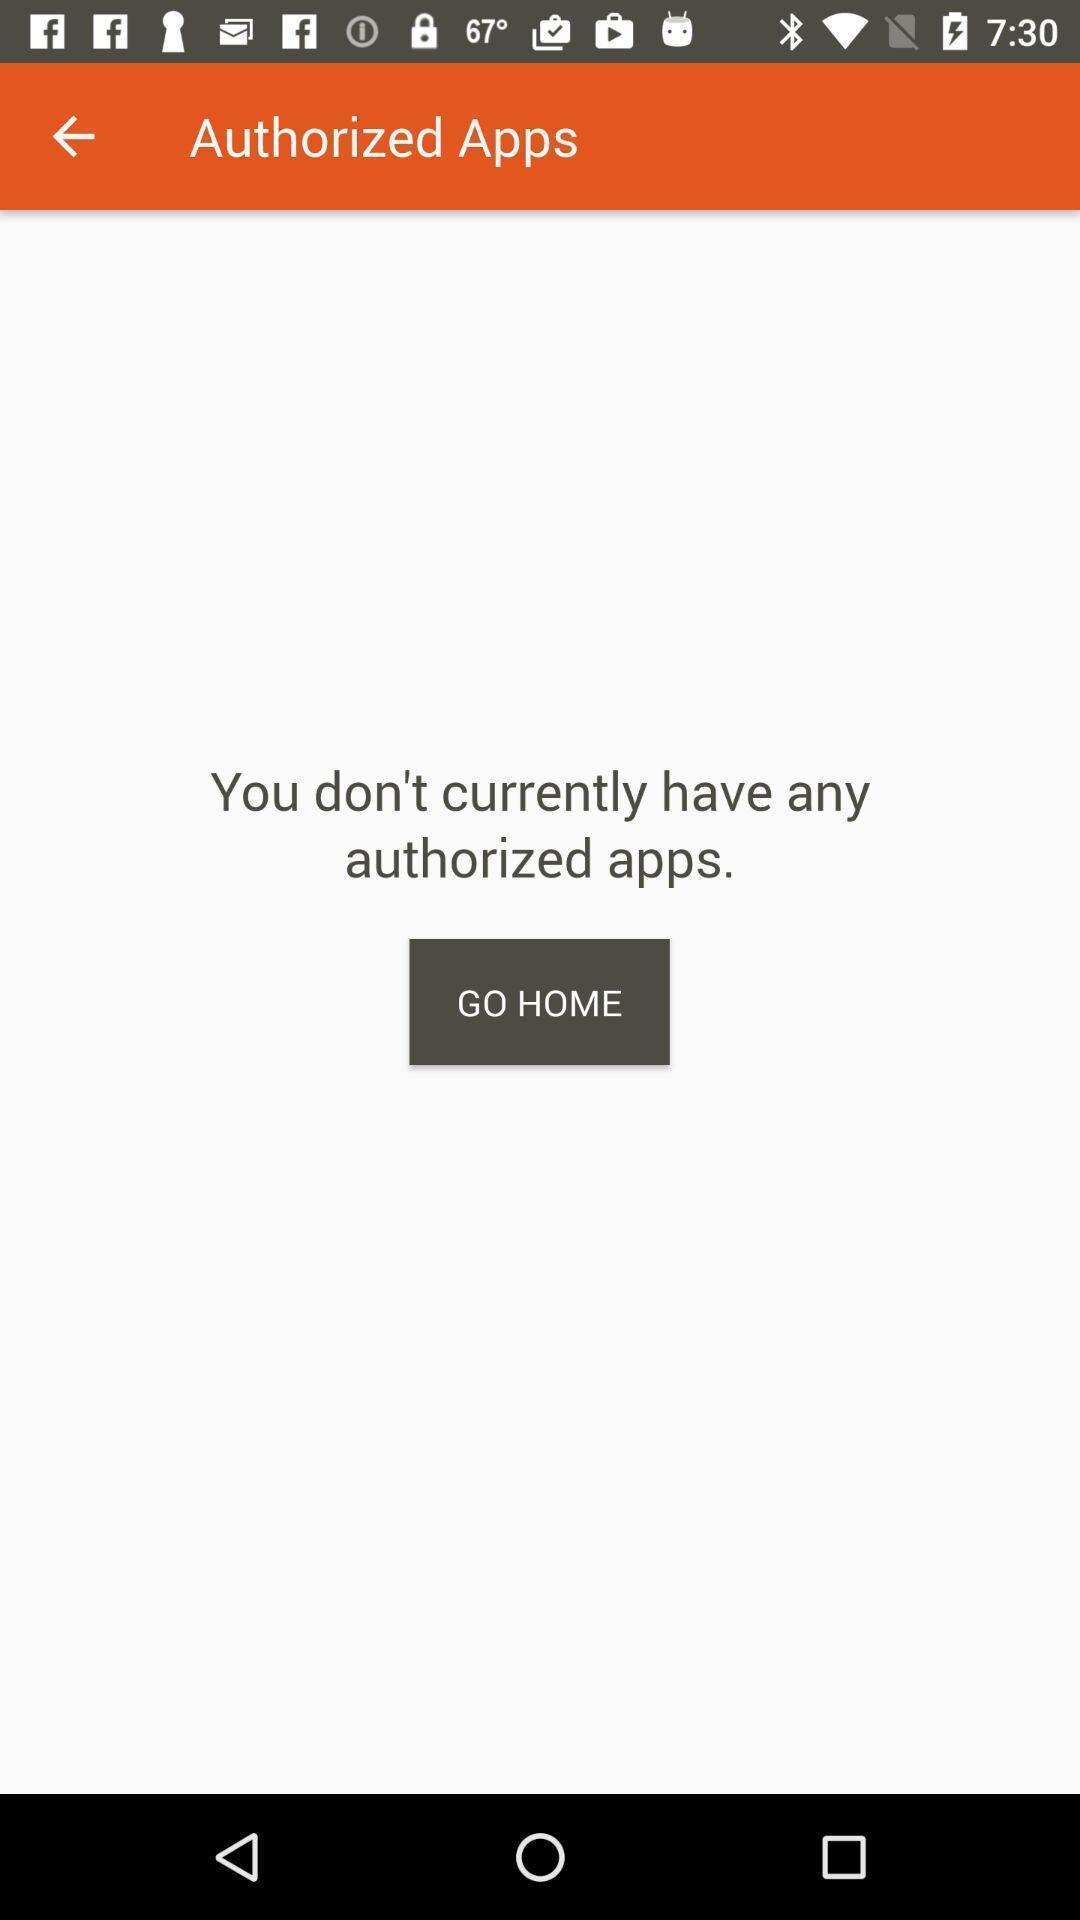What can you discern from this picture? Screen shows authorized apps details in page. 